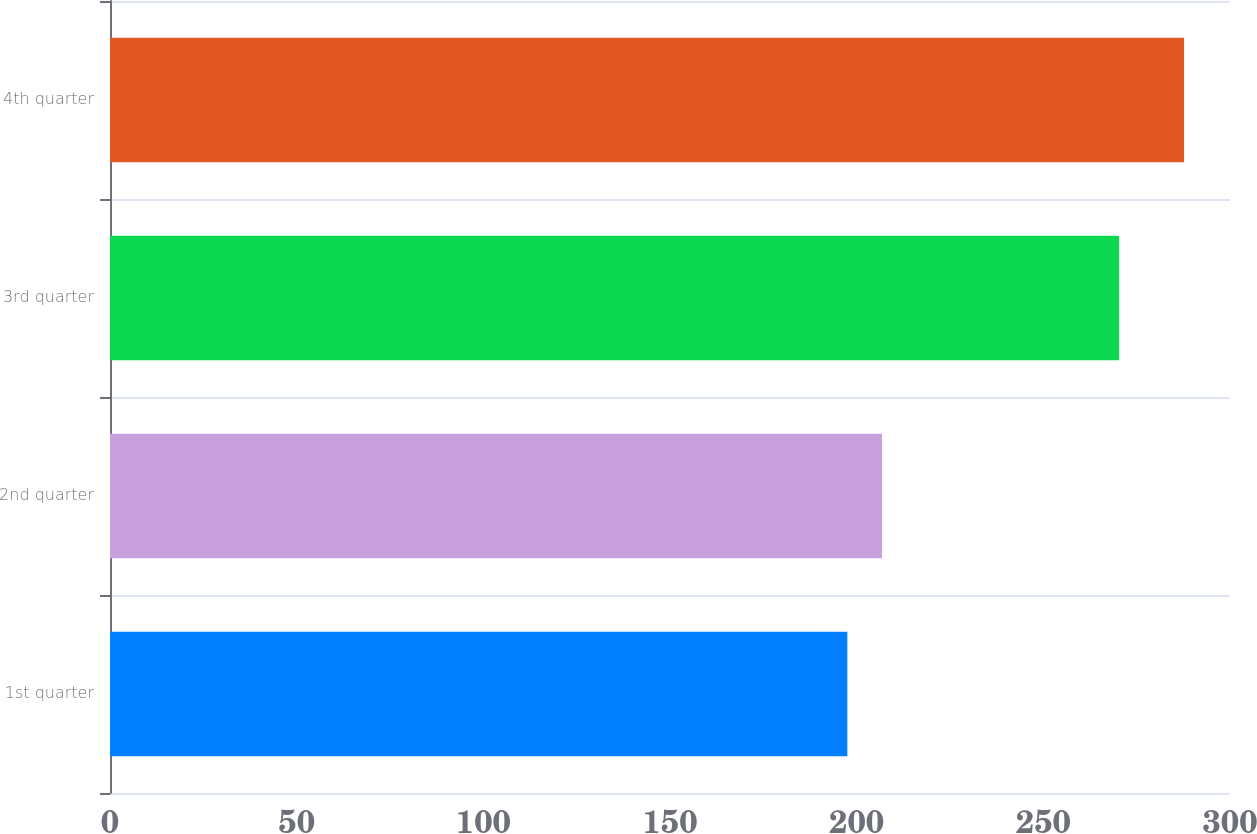Convert chart to OTSL. <chart><loc_0><loc_0><loc_500><loc_500><bar_chart><fcel>1st quarter<fcel>2nd quarter<fcel>3rd quarter<fcel>4th quarter<nl><fcel>197.5<fcel>206.8<fcel>270.3<fcel>287.7<nl></chart> 